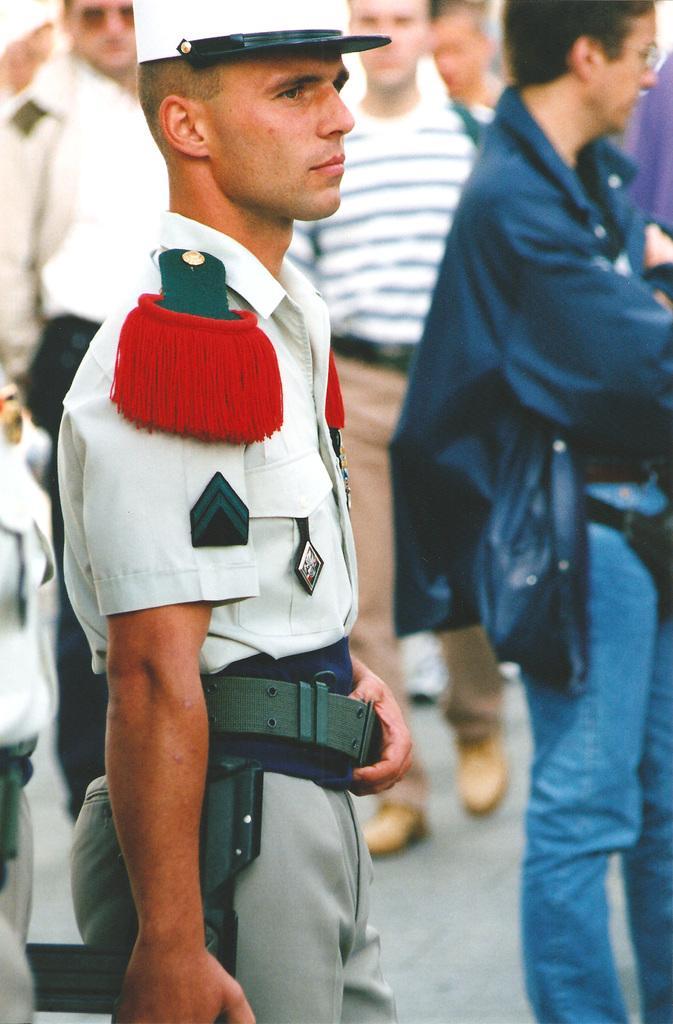Can you describe this image briefly? On the left side, there is a person in a uniform, holding a gun with a hand, holding a belt with other hand, standing and watching something. On the right side, there is a person in a violet color jacket, standing on the road. In the background, there are other persons on the road. 